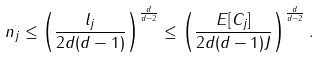<formula> <loc_0><loc_0><loc_500><loc_500>n _ { j } \leq \left ( \frac { l _ { j } } { 2 d ( d - 1 ) } \right ) ^ { \frac { d } { d - 2 } } \leq \left ( \frac { E [ C _ { j } ] } { 2 d ( d - 1 ) J } \right ) ^ { \frac { d } { d - 2 } } .</formula> 